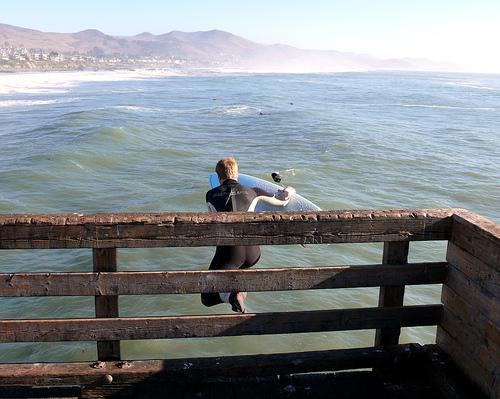How many men are there?
Give a very brief answer. 1. 